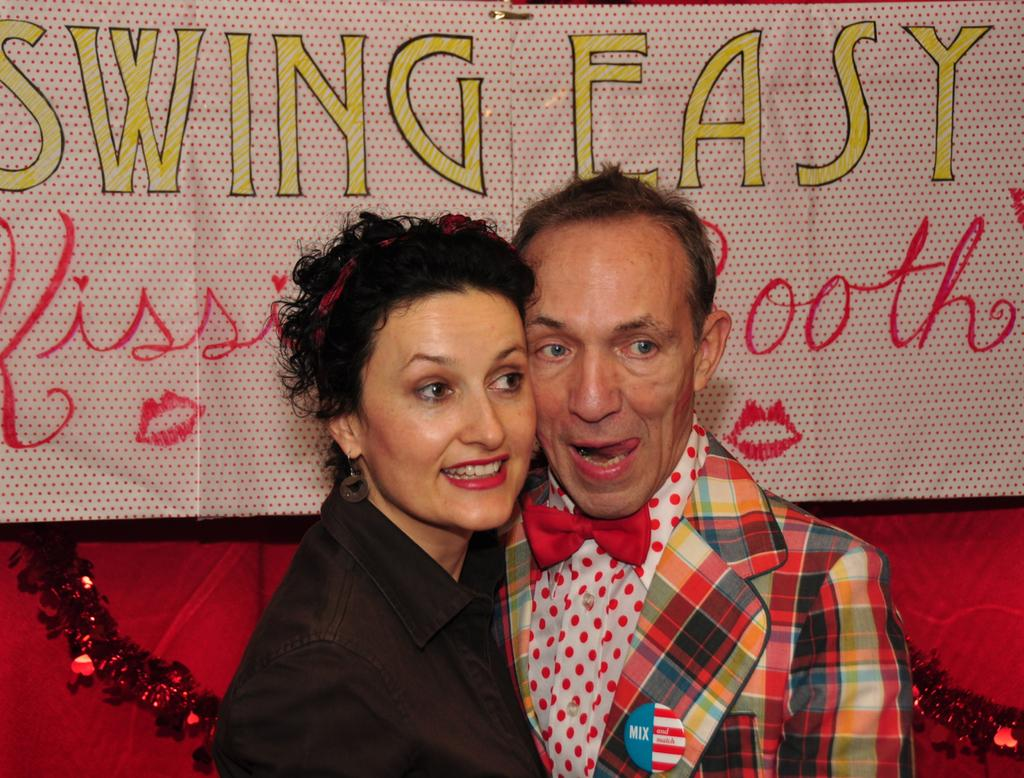How many people are in the image? There are two people in the image. What are the two people doing in the image? The two people are looking at something. How long does it take for the people's minds to stretch in the image? There is no indication in the image that the people's minds are stretching, so it cannot be determined from the picture. 